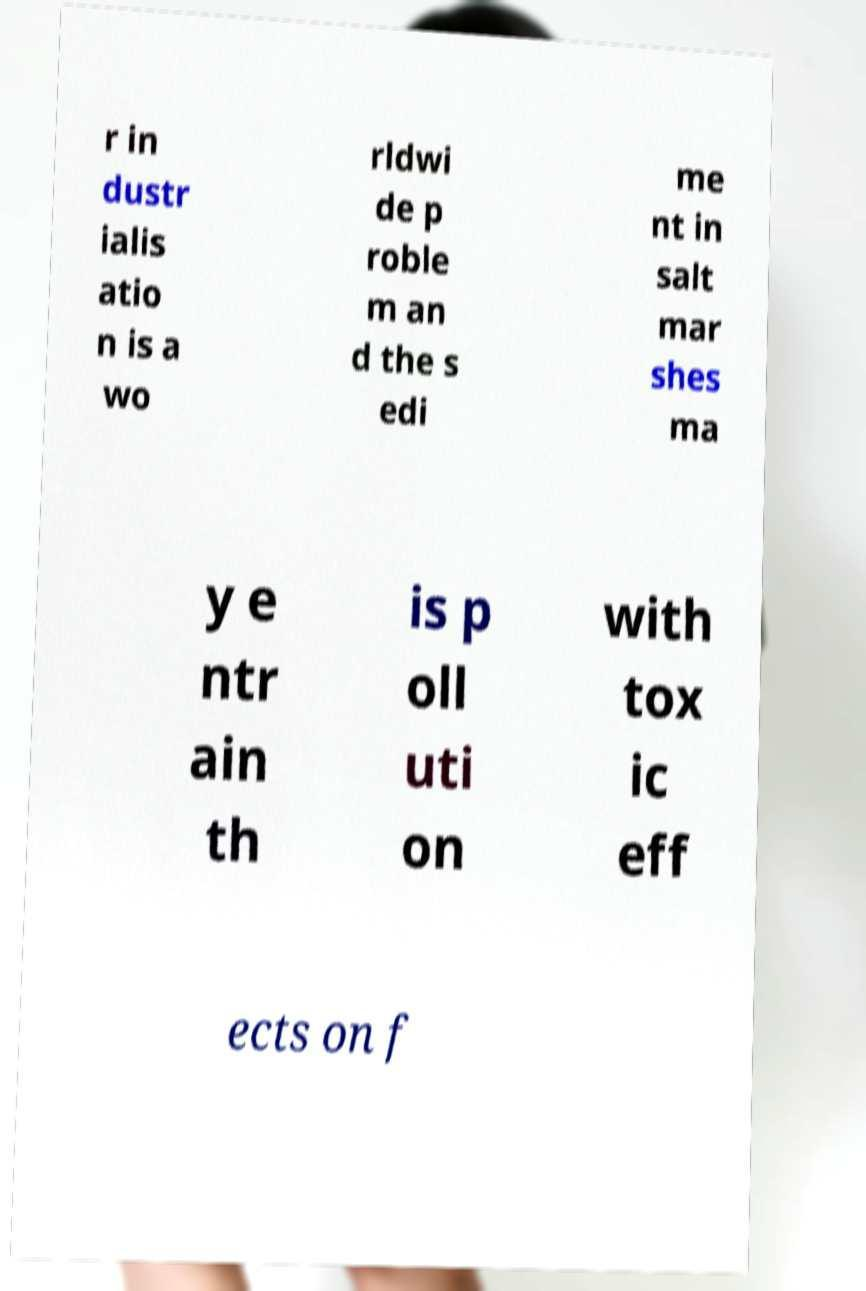Can you accurately transcribe the text from the provided image for me? r in dustr ialis atio n is a wo rldwi de p roble m an d the s edi me nt in salt mar shes ma y e ntr ain th is p oll uti on with tox ic eff ects on f 